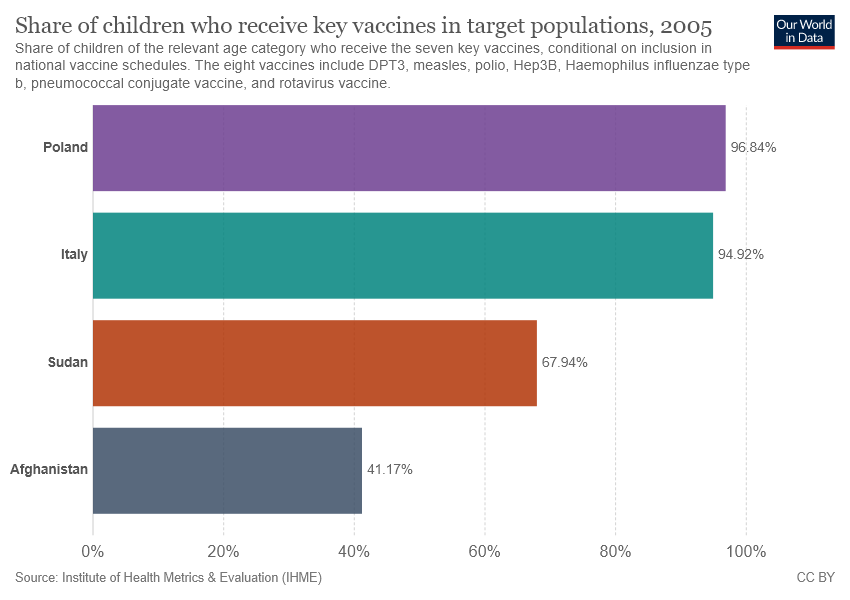Give some essential details in this illustration. Afghanistan has the lowest share of children who received key vaccines, which is a concern for public health. The median in the two top countries for the share of children who received the key vaccine was 0.9588. 